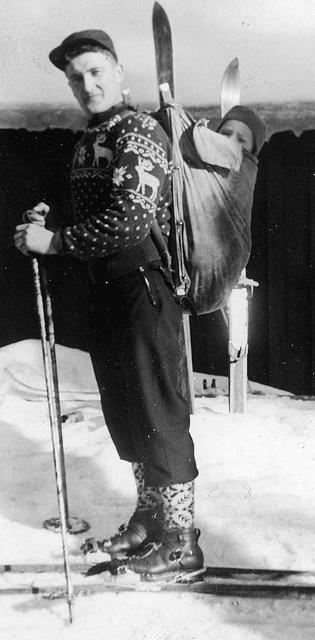What relation is the man to the boy in his backpack? father 